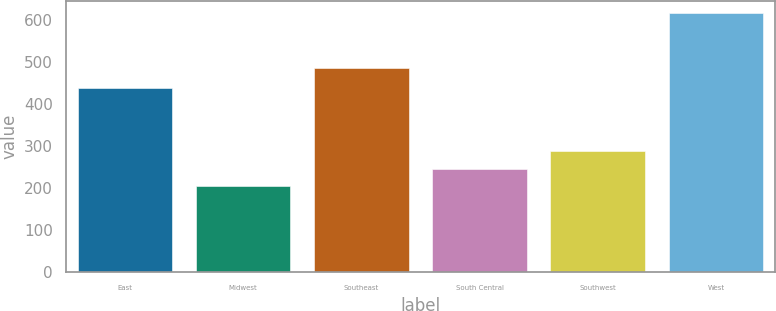<chart> <loc_0><loc_0><loc_500><loc_500><bar_chart><fcel>East<fcel>Midwest<fcel>Southeast<fcel>South Central<fcel>Southwest<fcel>West<nl><fcel>436.9<fcel>204.8<fcel>485.5<fcel>245.8<fcel>286.8<fcel>614.8<nl></chart> 